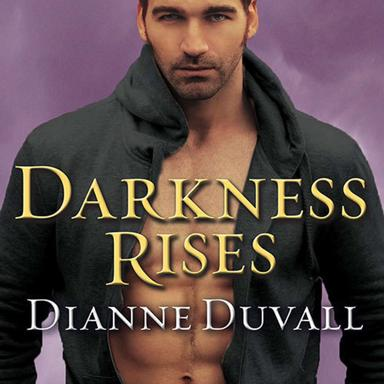What is "Darkness Rises"? "Darkness Rises" is a captivating paranormal romance novel authored by Dianne Duvall. It is part of the 'Immortal Guardians' series, known for blending elements of mystery, love, and supernatural adventures. 